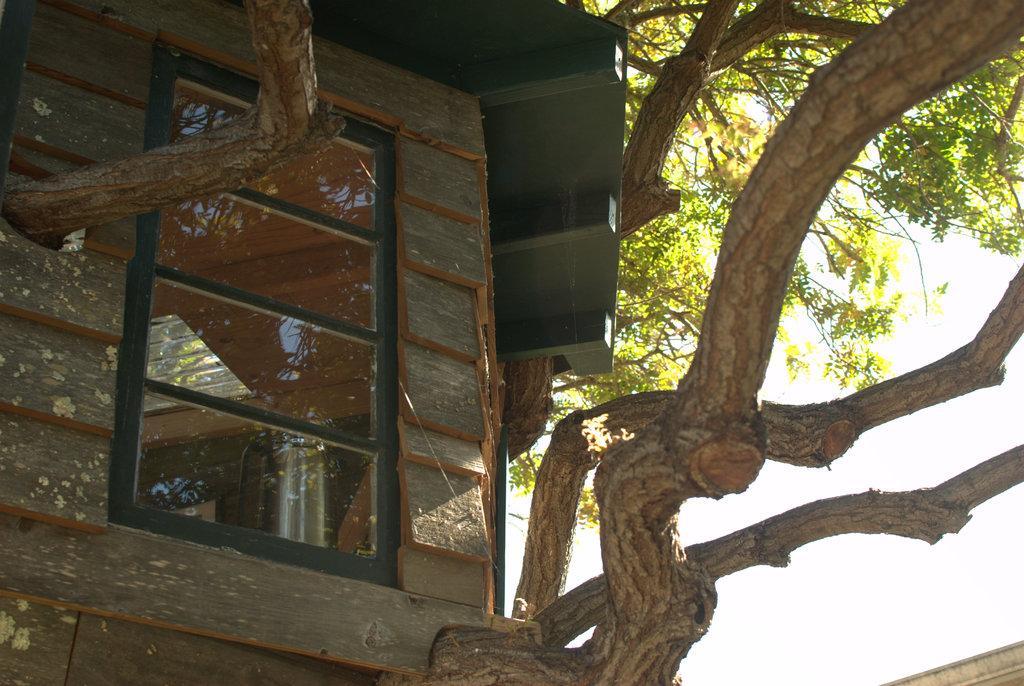Describe this image in one or two sentences. To the left side of the image we can see a building with windows. In the background, we can see a tree and the sky. 